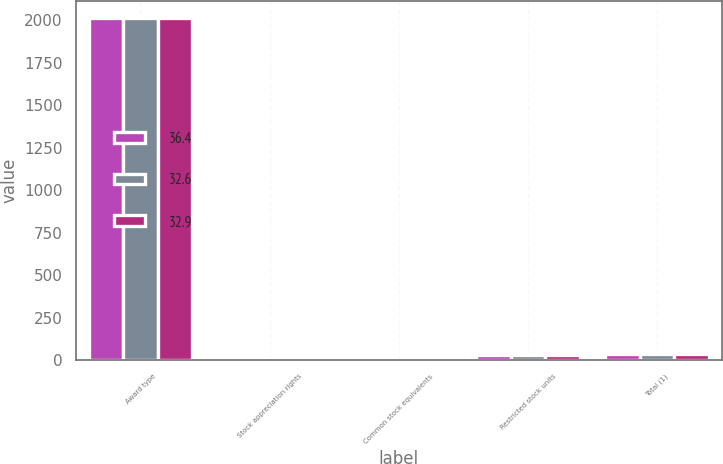<chart> <loc_0><loc_0><loc_500><loc_500><stacked_bar_chart><ecel><fcel>Award type<fcel>Stock appreciation rights<fcel>Common stock equivalents<fcel>Restricted stock units<fcel>Total (1)<nl><fcel>36.4<fcel>2012<fcel>6.4<fcel>0.5<fcel>29.5<fcel>36.4<nl><fcel>32.6<fcel>2011<fcel>4.4<fcel>0.5<fcel>28<fcel>32.9<nl><fcel>32.9<fcel>2010<fcel>4.6<fcel>0.5<fcel>27.5<fcel>32.6<nl></chart> 